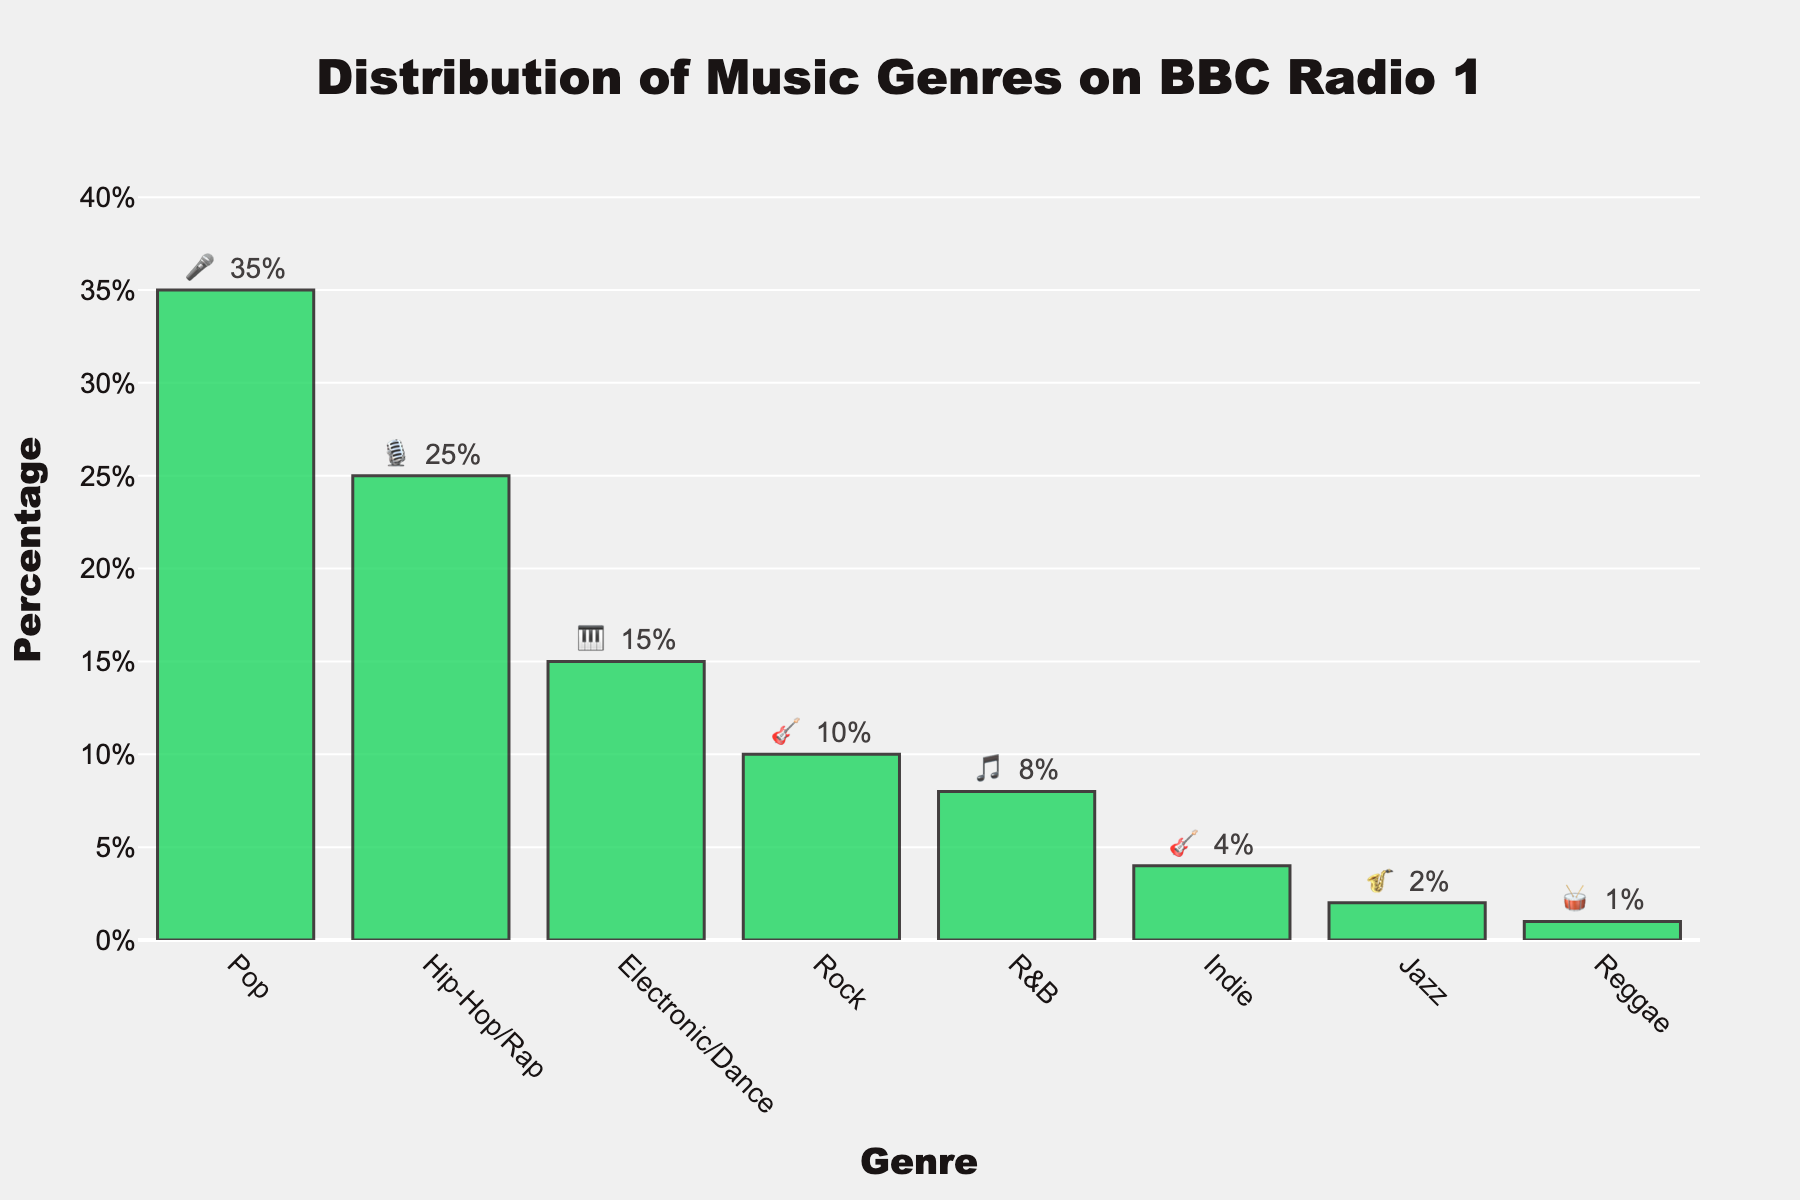what's the title of the chart? The title is located at the top center of the chart in a bigger font size. It reads "Distribution of Music Genres on BBC Radio 1".
Answer: Distribution of Music Genres on BBC Radio 1 which genre has the highest percentage and what is it? By looking at the bars' heights and the text labels above them, we can see that the genre with the highest percentage is Pop, with a value of 35%.
Answer: Pop, 35% what's the combined percentage of Pop and Hip-Hop/Rap? To find the combined percentage, add the percentage values of Pop and Hip-Hop/Rap. This is 35% + 25% = 60%.
Answer: 60% how much more popular is Electronic/Dance compared to Reggae? To determine the difference, subtract the percentage of Reggae from Electronic/Dance. This is 15% - 1% = 14%.
Answer: 14% which genre has the smallest percentage and what is it? The shortest bar represents the smallest percentage. The label next to it shows the genre is Reggae with 1%.
Answer: Reggae, 1% between Rock and Indie, which genre has a higher percentage and by how much? Rock has 10% and Indie has 4%. By subtracting these, Rock is 6% higher.
Answer: Rock, 6% how many genres have a percentage higher than 10%? Count the bars that have a percentage label greater than 10%. These genres are Pop (35%), Hip-Hop/Rap (25%), and Electronic/Dance (15%). There are 3 genres.
Answer: 3 genres what is the percentage of Jazz music? Refer to the text label above the bar for Jazz. It shows 2%.
Answer: 2% which genre is represented by the 🎸 emoji and what's its percentage? The genres with the 🎸 emoji are Rock and Indie. Rock has a 10% share and Indie has a 4% share.
Answer: Rock, 10%; Indie, 4% how does the percentage of R&B compare to Indie? R&B has 8% and Indie has 4%. Since 8% is greater than 4%, R&B is 4% higher than Indie.
Answer: R&B, 4% higher than Indie 